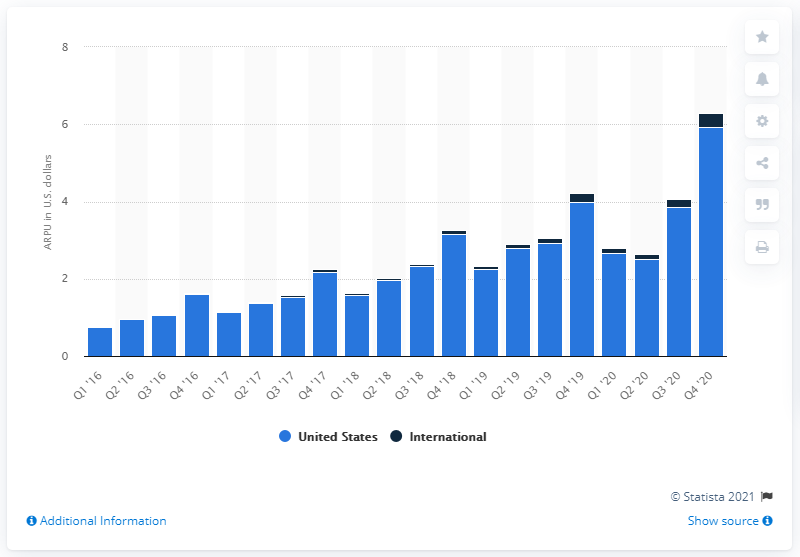Specify some key components in this picture. Pinterest's ARPU in the previous quarter was 3.85. 